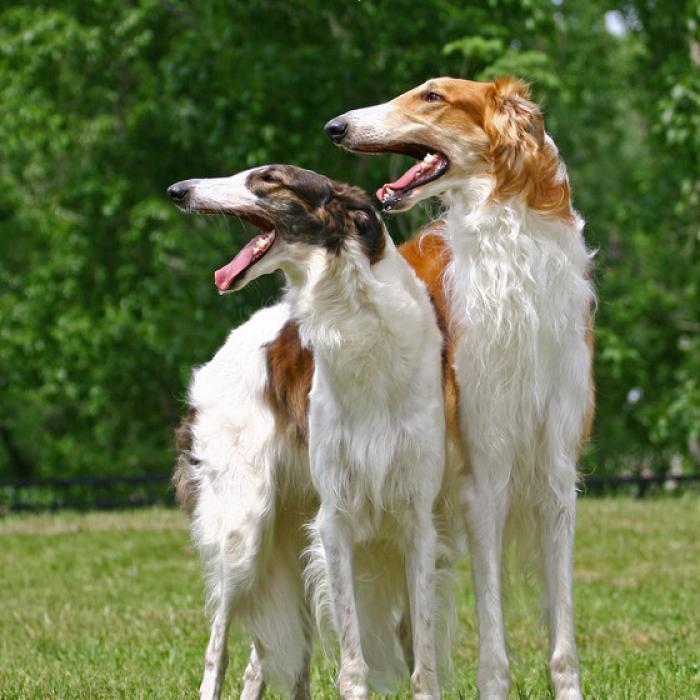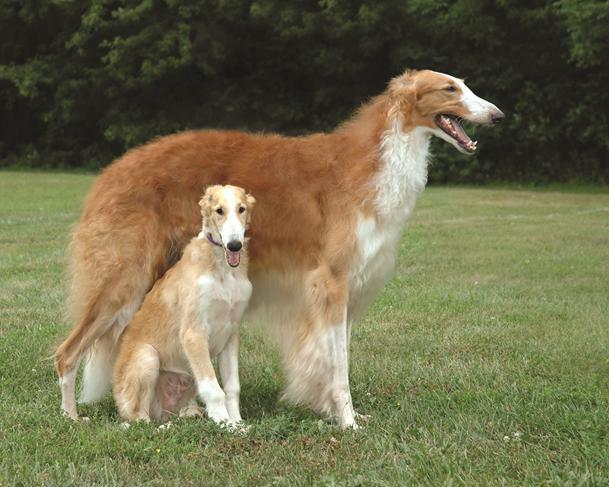The first image is the image on the left, the second image is the image on the right. Assess this claim about the two images: "There are at most 2 dogs.". Correct or not? Answer yes or no. No. The first image is the image on the left, the second image is the image on the right. Examine the images to the left and right. Is the description "Every dog has its mouth open." accurate? Answer yes or no. Yes. 